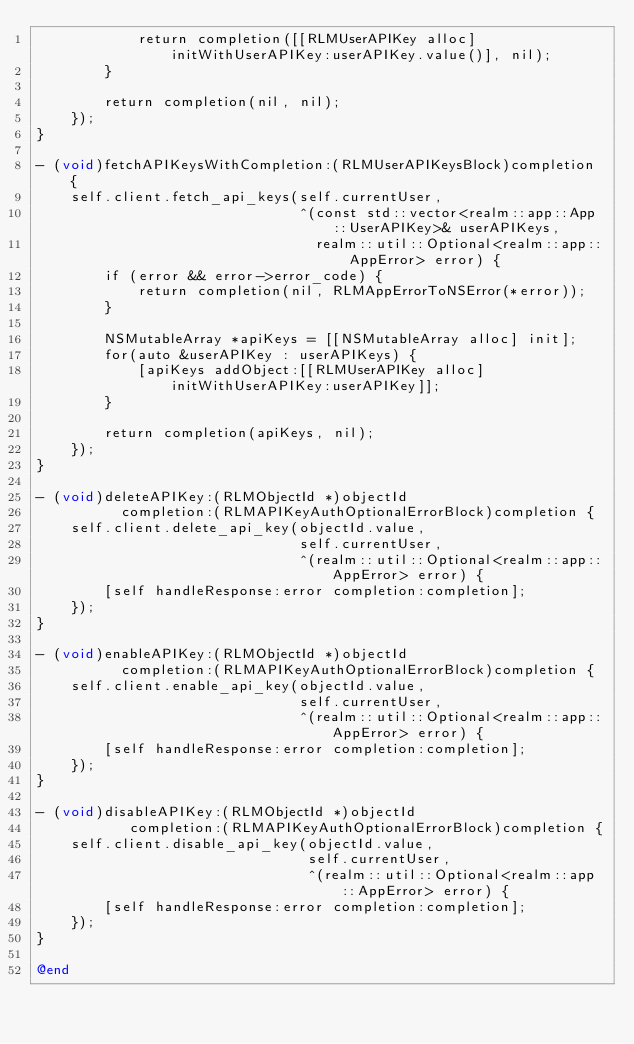<code> <loc_0><loc_0><loc_500><loc_500><_ObjectiveC_>            return completion([[RLMUserAPIKey alloc] initWithUserAPIKey:userAPIKey.value()], nil);
        }
        
        return completion(nil, nil);
    });
}

- (void)fetchAPIKeysWithCompletion:(RLMUserAPIKeysBlock)completion {
    self.client.fetch_api_keys(self.currentUser,
                               ^(const std::vector<realm::app::App::UserAPIKey>& userAPIKeys,
                                 realm::util::Optional<realm::app::AppError> error) {
        if (error && error->error_code) {
            return completion(nil, RLMAppErrorToNSError(*error));
        }
        
        NSMutableArray *apiKeys = [[NSMutableArray alloc] init];
        for(auto &userAPIKey : userAPIKeys) {
            [apiKeys addObject:[[RLMUserAPIKey alloc] initWithUserAPIKey:userAPIKey]];
        }
        
        return completion(apiKeys, nil);
    });
}

- (void)deleteAPIKey:(RLMObjectId *)objectId
          completion:(RLMAPIKeyAuthOptionalErrorBlock)completion {
    self.client.delete_api_key(objectId.value,
                               self.currentUser,
                               ^(realm::util::Optional<realm::app::AppError> error) {
        [self handleResponse:error completion:completion];
    });
}

- (void)enableAPIKey:(RLMObjectId *)objectId
          completion:(RLMAPIKeyAuthOptionalErrorBlock)completion {
    self.client.enable_api_key(objectId.value,
                               self.currentUser,
                               ^(realm::util::Optional<realm::app::AppError> error) {
        [self handleResponse:error completion:completion];
    });
}

- (void)disableAPIKey:(RLMObjectId *)objectId
           completion:(RLMAPIKeyAuthOptionalErrorBlock)completion {
    self.client.disable_api_key(objectId.value,
                                self.currentUser,
                                ^(realm::util::Optional<realm::app::AppError> error) {
        [self handleResponse:error completion:completion];
    });
}

@end
</code> 